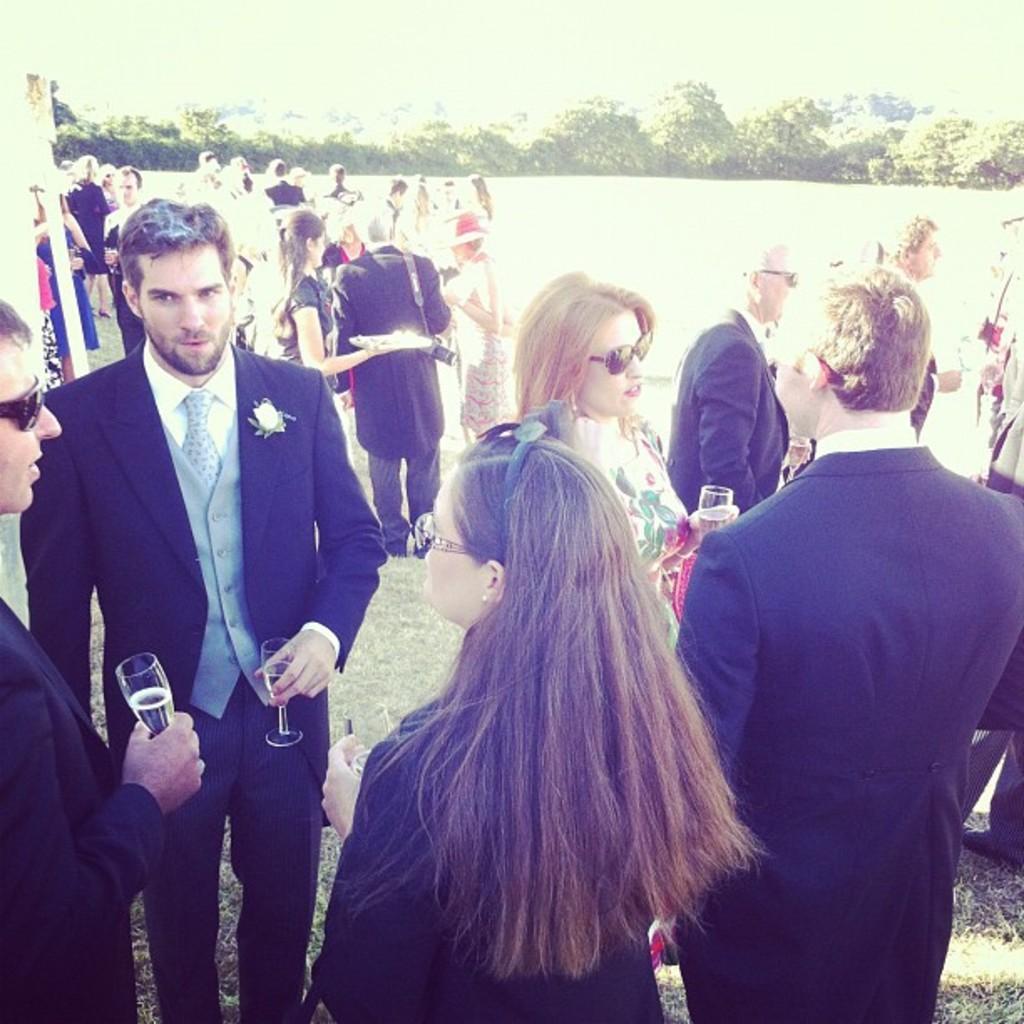In one or two sentences, can you explain what this image depicts? In this image we can see a few people, some of them are holding glasses, one person is holding a plate, there are plants. 